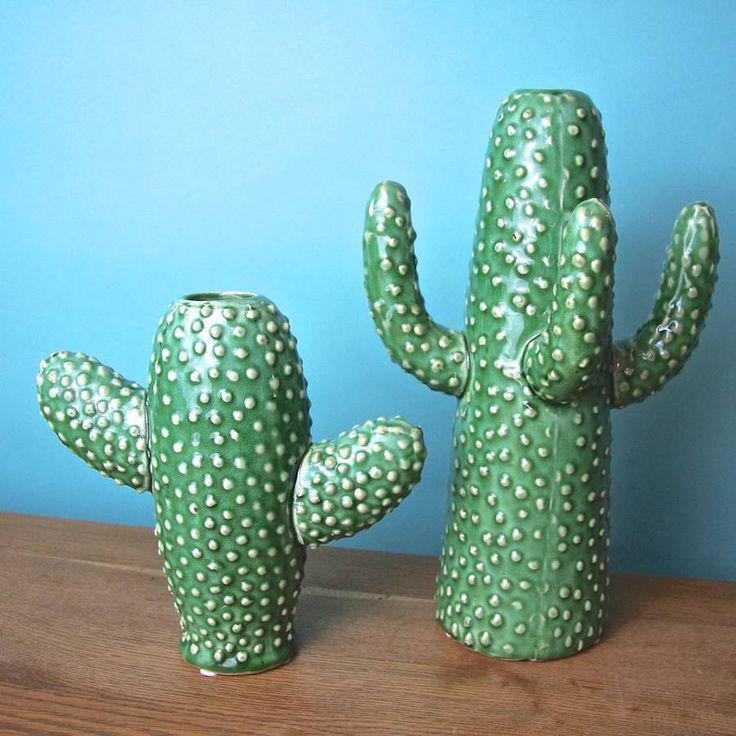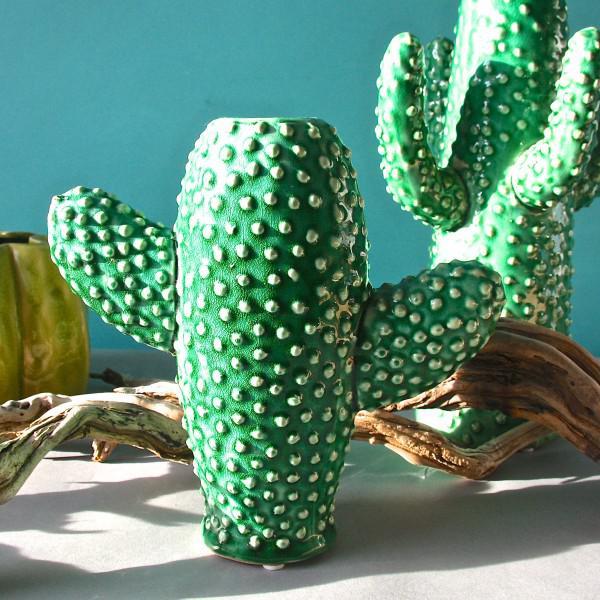The first image is the image on the left, the second image is the image on the right. Considering the images on both sides, is "At least one image features vases that look like cacti." valid? Answer yes or no. Yes. The first image is the image on the left, the second image is the image on the right. For the images shown, is this caption "At least one photo features cactus-shaped vases." true? Answer yes or no. Yes. 